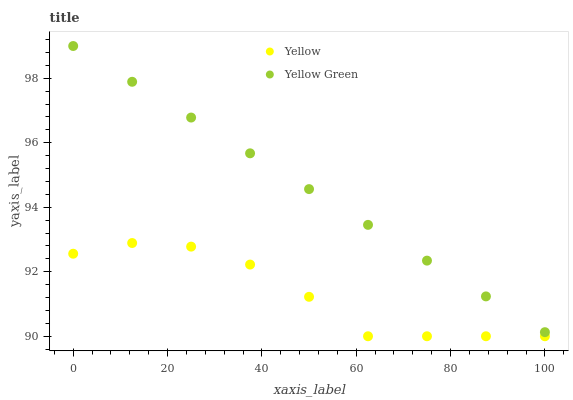Does Yellow have the minimum area under the curve?
Answer yes or no. Yes. Does Yellow Green have the maximum area under the curve?
Answer yes or no. Yes. Does Yellow have the maximum area under the curve?
Answer yes or no. No. Is Yellow Green the smoothest?
Answer yes or no. Yes. Is Yellow the roughest?
Answer yes or no. Yes. Is Yellow the smoothest?
Answer yes or no. No. Does Yellow have the lowest value?
Answer yes or no. Yes. Does Yellow Green have the highest value?
Answer yes or no. Yes. Does Yellow have the highest value?
Answer yes or no. No. Is Yellow less than Yellow Green?
Answer yes or no. Yes. Is Yellow Green greater than Yellow?
Answer yes or no. Yes. Does Yellow intersect Yellow Green?
Answer yes or no. No. 